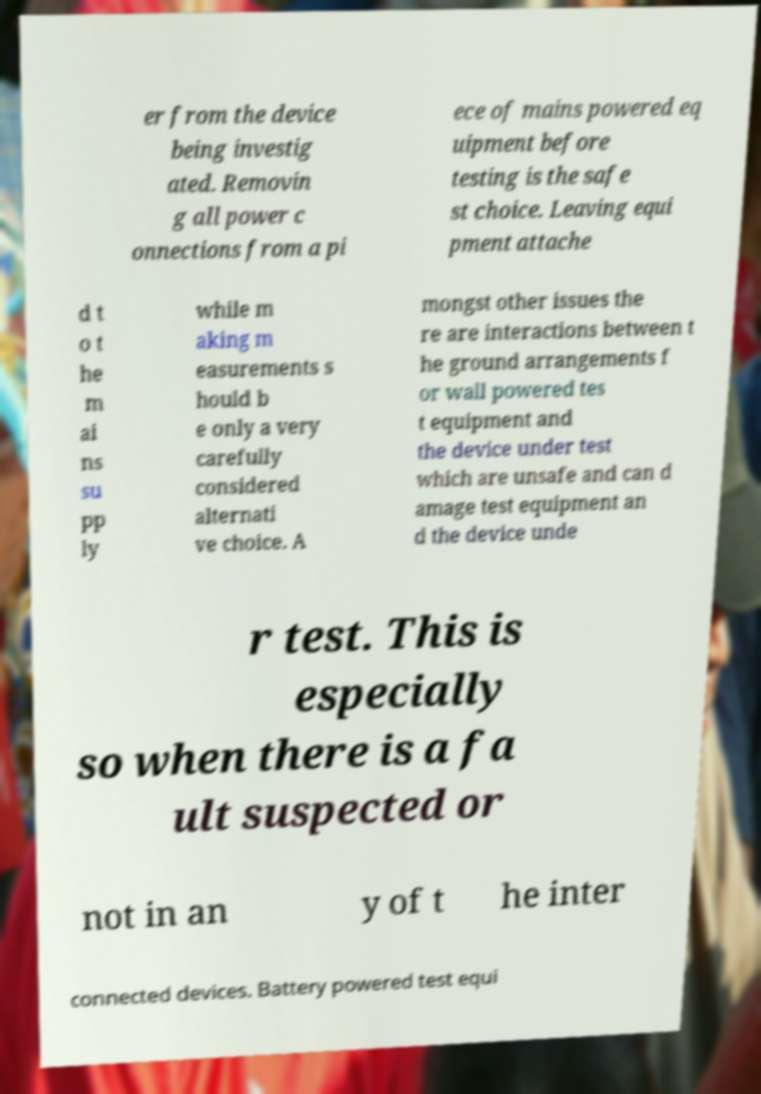For documentation purposes, I need the text within this image transcribed. Could you provide that? er from the device being investig ated. Removin g all power c onnections from a pi ece of mains powered eq uipment before testing is the safe st choice. Leaving equi pment attache d t o t he m ai ns su pp ly while m aking m easurements s hould b e only a very carefully considered alternati ve choice. A mongst other issues the re are interactions between t he ground arrangements f or wall powered tes t equipment and the device under test which are unsafe and can d amage test equipment an d the device unde r test. This is especially so when there is a fa ult suspected or not in an y of t he inter connected devices. Battery powered test equi 